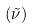Convert formula to latex. <formula><loc_0><loc_0><loc_500><loc_500>( \tilde { \nu } )</formula> 